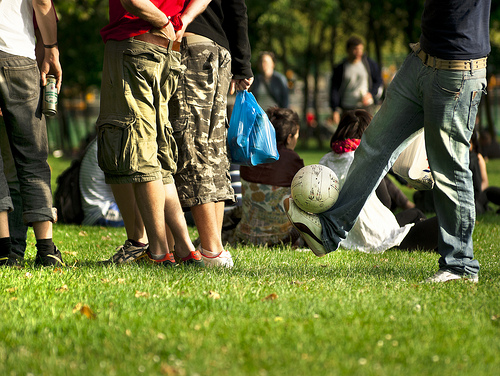<image>
Is there a hands in the pants? Yes. The hands is contained within or inside the pants, showing a containment relationship. Is the ball on the ankle? Yes. Looking at the image, I can see the ball is positioned on top of the ankle, with the ankle providing support. Is the ball in front of the ground? No. The ball is not in front of the ground. The spatial positioning shows a different relationship between these objects. 